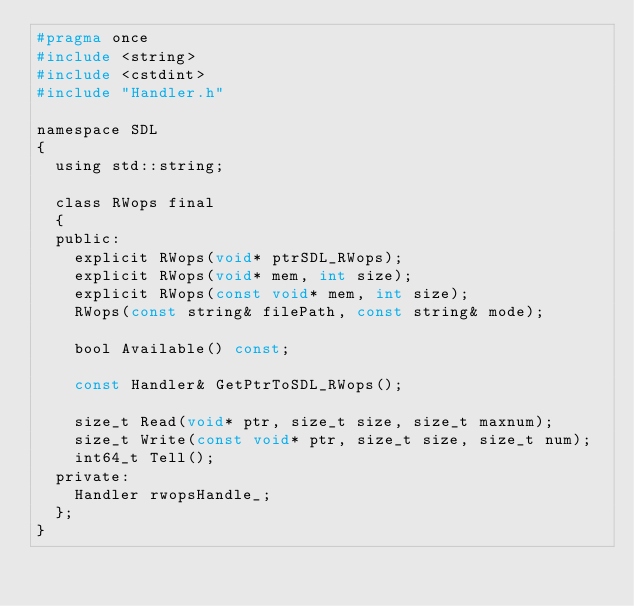Convert code to text. <code><loc_0><loc_0><loc_500><loc_500><_C_>#pragma once
#include <string>
#include <cstdint>
#include "Handler.h"

namespace SDL
{
	using std::string;

	class RWops final
	{
	public:
		explicit RWops(void* ptrSDL_RWops);
		explicit RWops(void* mem, int size);
		explicit RWops(const void* mem, int size);
		RWops(const string& filePath, const string& mode);

		bool Available() const;

		const Handler& GetPtrToSDL_RWops();
		
		size_t Read(void* ptr, size_t size, size_t maxnum);
		size_t Write(const void* ptr, size_t size, size_t num);
		int64_t Tell();
	private:
		Handler rwopsHandle_;
	};
}</code> 